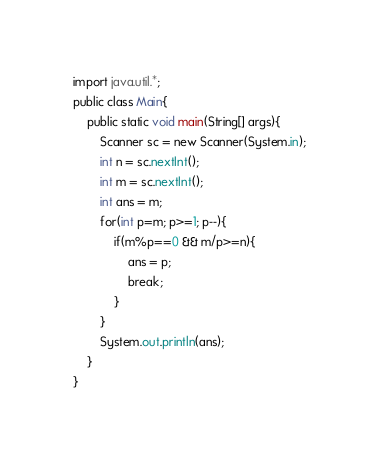<code> <loc_0><loc_0><loc_500><loc_500><_Java_>import java.util.*;
public class Main{
	public static void main(String[] args){
		Scanner sc = new Scanner(System.in);
		int n = sc.nextInt();
		int m = sc.nextInt();
		int ans = m;
		for(int p=m; p>=1; p--){
			if(m%p==0 && m/p>=n){
				ans = p;
              	break;
			}
		}
		System.out.println(ans);
	}
}</code> 